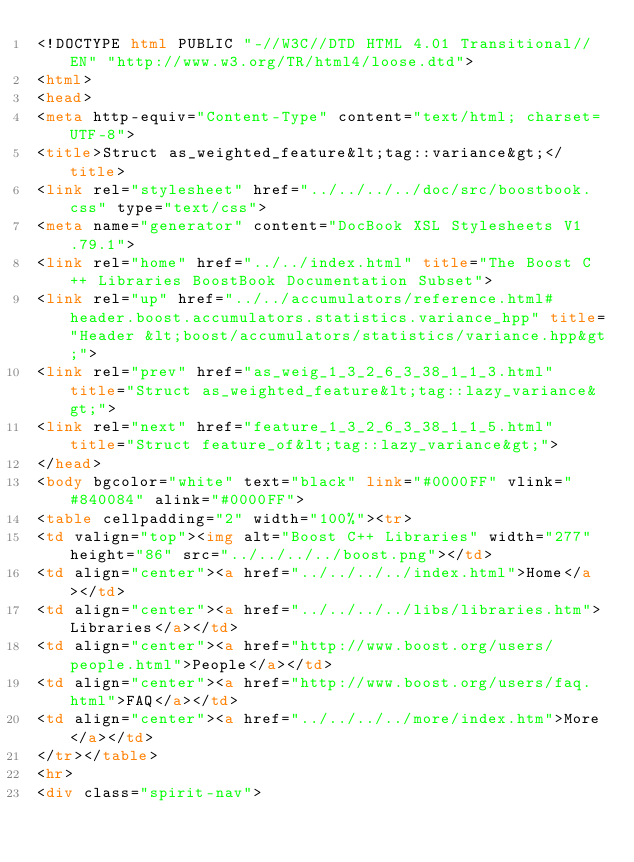Convert code to text. <code><loc_0><loc_0><loc_500><loc_500><_HTML_><!DOCTYPE html PUBLIC "-//W3C//DTD HTML 4.01 Transitional//EN" "http://www.w3.org/TR/html4/loose.dtd">
<html>
<head>
<meta http-equiv="Content-Type" content="text/html; charset=UTF-8">
<title>Struct as_weighted_feature&lt;tag::variance&gt;</title>
<link rel="stylesheet" href="../../../../doc/src/boostbook.css" type="text/css">
<meta name="generator" content="DocBook XSL Stylesheets V1.79.1">
<link rel="home" href="../../index.html" title="The Boost C++ Libraries BoostBook Documentation Subset">
<link rel="up" href="../../accumulators/reference.html#header.boost.accumulators.statistics.variance_hpp" title="Header &lt;boost/accumulators/statistics/variance.hpp&gt;">
<link rel="prev" href="as_weig_1_3_2_6_3_38_1_1_3.html" title="Struct as_weighted_feature&lt;tag::lazy_variance&gt;">
<link rel="next" href="feature_1_3_2_6_3_38_1_1_5.html" title="Struct feature_of&lt;tag::lazy_variance&gt;">
</head>
<body bgcolor="white" text="black" link="#0000FF" vlink="#840084" alink="#0000FF">
<table cellpadding="2" width="100%"><tr>
<td valign="top"><img alt="Boost C++ Libraries" width="277" height="86" src="../../../../boost.png"></td>
<td align="center"><a href="../../../../index.html">Home</a></td>
<td align="center"><a href="../../../../libs/libraries.htm">Libraries</a></td>
<td align="center"><a href="http://www.boost.org/users/people.html">People</a></td>
<td align="center"><a href="http://www.boost.org/users/faq.html">FAQ</a></td>
<td align="center"><a href="../../../../more/index.htm">More</a></td>
</tr></table>
<hr>
<div class="spirit-nav"></code> 